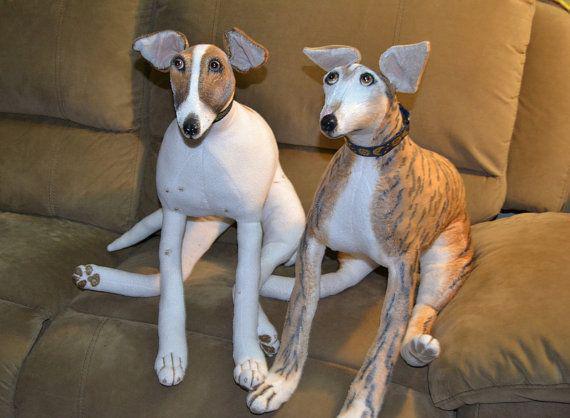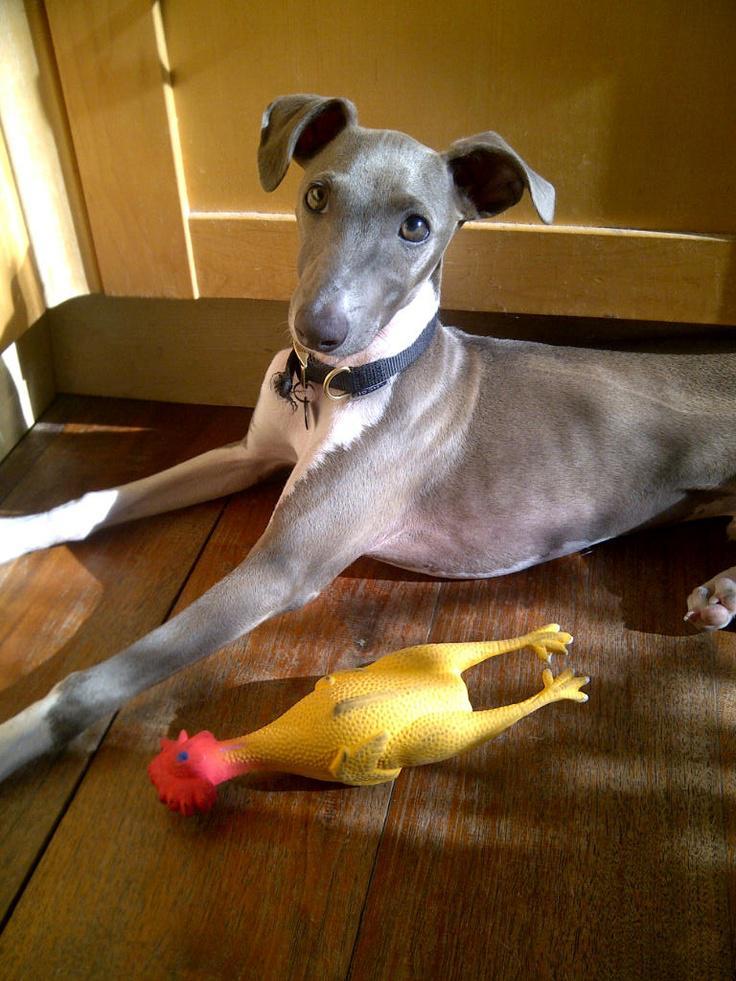The first image is the image on the left, the second image is the image on the right. Given the left and right images, does the statement "Each image features a single dog, and one dog looks rightward while the other is facing forward." hold true? Answer yes or no. No. The first image is the image on the left, the second image is the image on the right. For the images shown, is this caption "Two dogs are sitting together on a piece of furniture in the image on the left." true? Answer yes or no. Yes. 